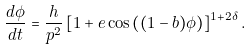<formula> <loc_0><loc_0><loc_500><loc_500>\frac { d \phi } { d t } = \frac { h } { p ^ { 2 } } \left [ 1 + e \cos \left ( ( 1 - b ) \phi \right ) \right ] ^ { 1 + 2 \delta } .</formula> 